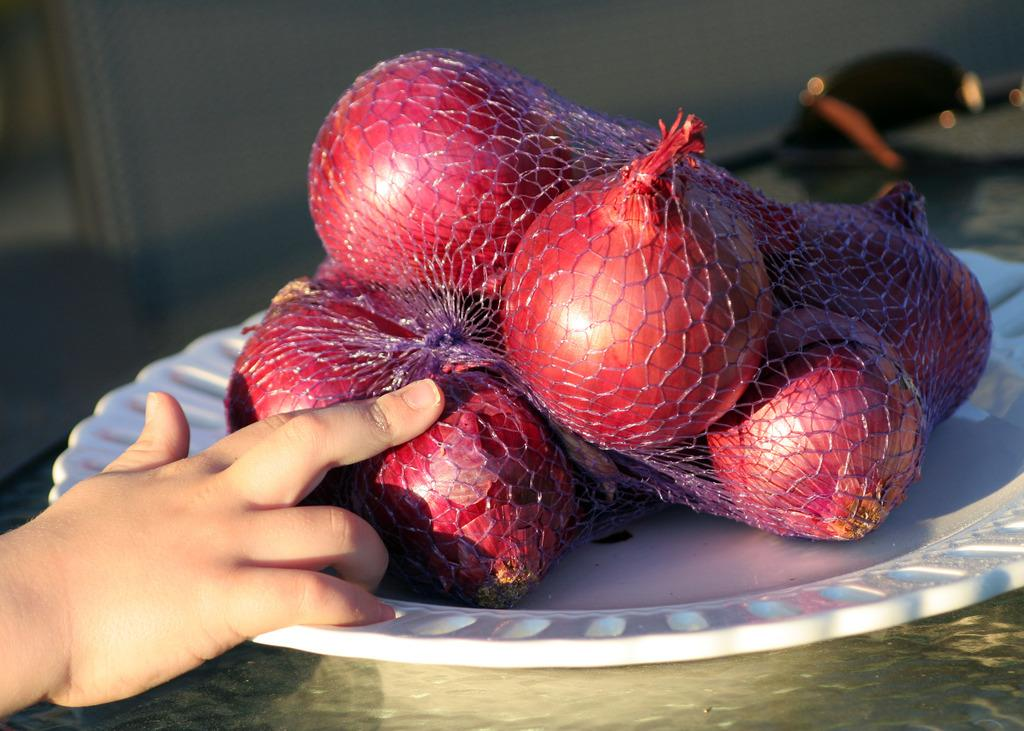What type of food item is present in the image? There are onions in the image. How are the onions arranged or displayed? The onions are in a white color plate. Can you identify any body parts of a person in the image? Yes, there is a hand of a person visible in the image. How many geese are swimming around the island in the image? There are no geese or islands present in the image; it features onions in a white color plate and a hand. What type of cows can be seen grazing on the grass in the image? There are no cows or grass present in the image; it only contains onions in a white color plate and a hand. 